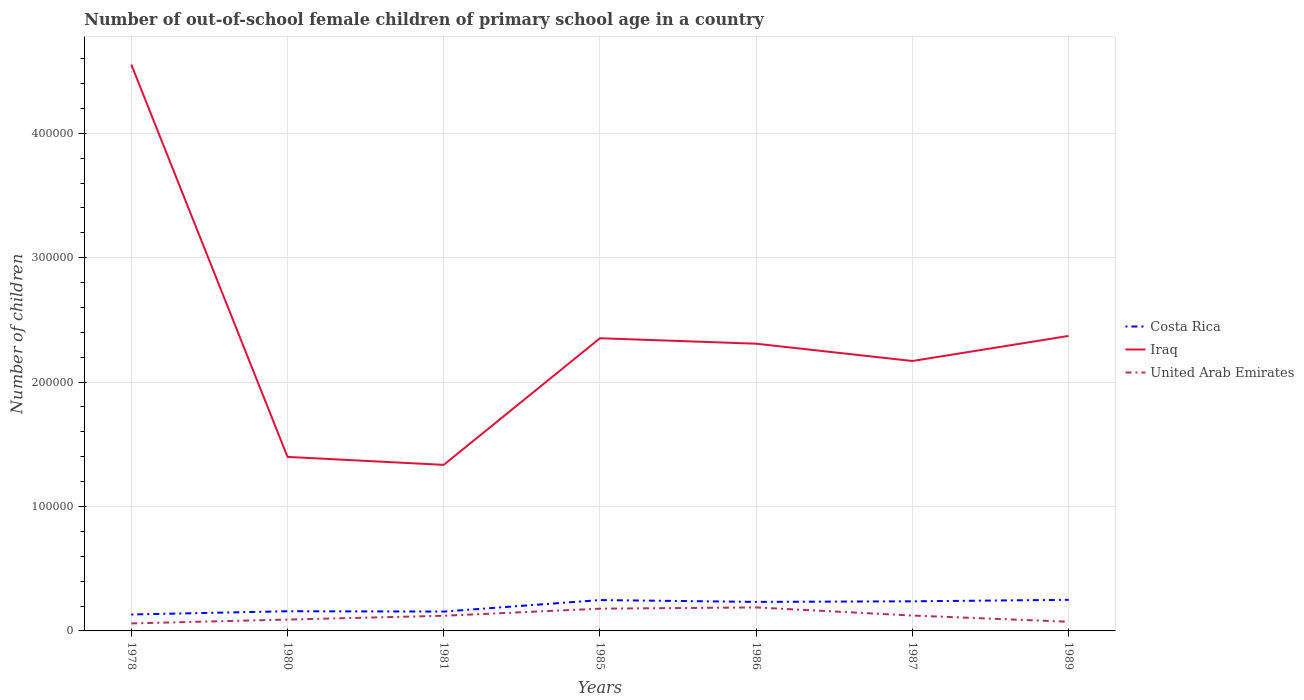How many different coloured lines are there?
Offer a very short reply. 3. Does the line corresponding to Costa Rica intersect with the line corresponding to Iraq?
Your response must be concise. No. Across all years, what is the maximum number of out-of-school female children in Costa Rica?
Your answer should be compact. 1.32e+04. In which year was the number of out-of-school female children in Iraq maximum?
Your answer should be very brief. 1981. What is the total number of out-of-school female children in United Arab Emirates in the graph?
Ensure brevity in your answer.  4973. What is the difference between the highest and the second highest number of out-of-school female children in Iraq?
Ensure brevity in your answer.  3.22e+05. How many lines are there?
Your response must be concise. 3. How many years are there in the graph?
Keep it short and to the point. 7. What is the difference between two consecutive major ticks on the Y-axis?
Provide a succinct answer. 1.00e+05. Are the values on the major ticks of Y-axis written in scientific E-notation?
Ensure brevity in your answer.  No. Does the graph contain any zero values?
Your answer should be very brief. No. Does the graph contain grids?
Offer a very short reply. Yes. Where does the legend appear in the graph?
Make the answer very short. Center right. How many legend labels are there?
Give a very brief answer. 3. How are the legend labels stacked?
Provide a succinct answer. Vertical. What is the title of the graph?
Make the answer very short. Number of out-of-school female children of primary school age in a country. What is the label or title of the Y-axis?
Provide a short and direct response. Number of children. What is the Number of children of Costa Rica in 1978?
Keep it short and to the point. 1.32e+04. What is the Number of children in Iraq in 1978?
Your answer should be very brief. 4.55e+05. What is the Number of children of United Arab Emirates in 1978?
Give a very brief answer. 6031. What is the Number of children in Costa Rica in 1980?
Make the answer very short. 1.58e+04. What is the Number of children of Iraq in 1980?
Keep it short and to the point. 1.40e+05. What is the Number of children of United Arab Emirates in 1980?
Ensure brevity in your answer.  9125. What is the Number of children in Costa Rica in 1981?
Your answer should be very brief. 1.56e+04. What is the Number of children of Iraq in 1981?
Ensure brevity in your answer.  1.33e+05. What is the Number of children of United Arab Emirates in 1981?
Keep it short and to the point. 1.22e+04. What is the Number of children of Costa Rica in 1985?
Offer a terse response. 2.48e+04. What is the Number of children of Iraq in 1985?
Offer a very short reply. 2.35e+05. What is the Number of children in United Arab Emirates in 1985?
Give a very brief answer. 1.79e+04. What is the Number of children of Costa Rica in 1986?
Your answer should be very brief. 2.33e+04. What is the Number of children in Iraq in 1986?
Your answer should be compact. 2.31e+05. What is the Number of children of United Arab Emirates in 1986?
Provide a short and direct response. 1.89e+04. What is the Number of children in Costa Rica in 1987?
Keep it short and to the point. 2.38e+04. What is the Number of children of Iraq in 1987?
Ensure brevity in your answer.  2.17e+05. What is the Number of children of United Arab Emirates in 1987?
Give a very brief answer. 1.24e+04. What is the Number of children of Costa Rica in 1989?
Provide a short and direct response. 2.50e+04. What is the Number of children in Iraq in 1989?
Provide a succinct answer. 2.37e+05. What is the Number of children of United Arab Emirates in 1989?
Ensure brevity in your answer.  7385. Across all years, what is the maximum Number of children of Costa Rica?
Make the answer very short. 2.50e+04. Across all years, what is the maximum Number of children of Iraq?
Give a very brief answer. 4.55e+05. Across all years, what is the maximum Number of children of United Arab Emirates?
Offer a very short reply. 1.89e+04. Across all years, what is the minimum Number of children of Costa Rica?
Offer a very short reply. 1.32e+04. Across all years, what is the minimum Number of children of Iraq?
Keep it short and to the point. 1.33e+05. Across all years, what is the minimum Number of children of United Arab Emirates?
Make the answer very short. 6031. What is the total Number of children of Costa Rica in the graph?
Your answer should be very brief. 1.42e+05. What is the total Number of children of Iraq in the graph?
Provide a succinct answer. 1.65e+06. What is the total Number of children in United Arab Emirates in the graph?
Your answer should be compact. 8.38e+04. What is the difference between the Number of children of Costa Rica in 1978 and that in 1980?
Your answer should be very brief. -2627. What is the difference between the Number of children in Iraq in 1978 and that in 1980?
Provide a succinct answer. 3.15e+05. What is the difference between the Number of children of United Arab Emirates in 1978 and that in 1980?
Offer a terse response. -3094. What is the difference between the Number of children in Costa Rica in 1978 and that in 1981?
Your response must be concise. -2364. What is the difference between the Number of children of Iraq in 1978 and that in 1981?
Keep it short and to the point. 3.22e+05. What is the difference between the Number of children in United Arab Emirates in 1978 and that in 1981?
Your answer should be very brief. -6150. What is the difference between the Number of children of Costa Rica in 1978 and that in 1985?
Provide a succinct answer. -1.16e+04. What is the difference between the Number of children of Iraq in 1978 and that in 1985?
Your answer should be very brief. 2.20e+05. What is the difference between the Number of children in United Arab Emirates in 1978 and that in 1985?
Offer a very short reply. -1.19e+04. What is the difference between the Number of children of Costa Rica in 1978 and that in 1986?
Provide a succinct answer. -1.01e+04. What is the difference between the Number of children of Iraq in 1978 and that in 1986?
Make the answer very short. 2.24e+05. What is the difference between the Number of children of United Arab Emirates in 1978 and that in 1986?
Provide a succinct answer. -1.29e+04. What is the difference between the Number of children in Costa Rica in 1978 and that in 1987?
Provide a succinct answer. -1.06e+04. What is the difference between the Number of children in Iraq in 1978 and that in 1987?
Give a very brief answer. 2.38e+05. What is the difference between the Number of children of United Arab Emirates in 1978 and that in 1987?
Your response must be concise. -6327. What is the difference between the Number of children of Costa Rica in 1978 and that in 1989?
Offer a very short reply. -1.18e+04. What is the difference between the Number of children in Iraq in 1978 and that in 1989?
Your response must be concise. 2.18e+05. What is the difference between the Number of children of United Arab Emirates in 1978 and that in 1989?
Offer a very short reply. -1354. What is the difference between the Number of children of Costa Rica in 1980 and that in 1981?
Provide a succinct answer. 263. What is the difference between the Number of children in Iraq in 1980 and that in 1981?
Keep it short and to the point. 6397. What is the difference between the Number of children of United Arab Emirates in 1980 and that in 1981?
Offer a very short reply. -3056. What is the difference between the Number of children in Costa Rica in 1980 and that in 1985?
Provide a succinct answer. -8973. What is the difference between the Number of children in Iraq in 1980 and that in 1985?
Offer a very short reply. -9.54e+04. What is the difference between the Number of children of United Arab Emirates in 1980 and that in 1985?
Your answer should be very brief. -8760. What is the difference between the Number of children of Costa Rica in 1980 and that in 1986?
Provide a succinct answer. -7512. What is the difference between the Number of children of Iraq in 1980 and that in 1986?
Offer a terse response. -9.10e+04. What is the difference between the Number of children in United Arab Emirates in 1980 and that in 1986?
Ensure brevity in your answer.  -9758. What is the difference between the Number of children in Costa Rica in 1980 and that in 1987?
Provide a short and direct response. -7978. What is the difference between the Number of children in Iraq in 1980 and that in 1987?
Give a very brief answer. -7.71e+04. What is the difference between the Number of children in United Arab Emirates in 1980 and that in 1987?
Provide a short and direct response. -3233. What is the difference between the Number of children of Costa Rica in 1980 and that in 1989?
Provide a short and direct response. -9174. What is the difference between the Number of children in Iraq in 1980 and that in 1989?
Keep it short and to the point. -9.72e+04. What is the difference between the Number of children of United Arab Emirates in 1980 and that in 1989?
Your response must be concise. 1740. What is the difference between the Number of children of Costa Rica in 1981 and that in 1985?
Your answer should be very brief. -9236. What is the difference between the Number of children in Iraq in 1981 and that in 1985?
Ensure brevity in your answer.  -1.02e+05. What is the difference between the Number of children of United Arab Emirates in 1981 and that in 1985?
Your response must be concise. -5704. What is the difference between the Number of children of Costa Rica in 1981 and that in 1986?
Your answer should be very brief. -7775. What is the difference between the Number of children in Iraq in 1981 and that in 1986?
Offer a very short reply. -9.74e+04. What is the difference between the Number of children in United Arab Emirates in 1981 and that in 1986?
Offer a terse response. -6702. What is the difference between the Number of children of Costa Rica in 1981 and that in 1987?
Offer a very short reply. -8241. What is the difference between the Number of children of Iraq in 1981 and that in 1987?
Keep it short and to the point. -8.35e+04. What is the difference between the Number of children in United Arab Emirates in 1981 and that in 1987?
Your response must be concise. -177. What is the difference between the Number of children of Costa Rica in 1981 and that in 1989?
Offer a terse response. -9437. What is the difference between the Number of children of Iraq in 1981 and that in 1989?
Keep it short and to the point. -1.04e+05. What is the difference between the Number of children of United Arab Emirates in 1981 and that in 1989?
Your answer should be compact. 4796. What is the difference between the Number of children of Costa Rica in 1985 and that in 1986?
Give a very brief answer. 1461. What is the difference between the Number of children of Iraq in 1985 and that in 1986?
Ensure brevity in your answer.  4392. What is the difference between the Number of children in United Arab Emirates in 1985 and that in 1986?
Your answer should be very brief. -998. What is the difference between the Number of children of Costa Rica in 1985 and that in 1987?
Your answer should be very brief. 995. What is the difference between the Number of children of Iraq in 1985 and that in 1987?
Ensure brevity in your answer.  1.83e+04. What is the difference between the Number of children in United Arab Emirates in 1985 and that in 1987?
Make the answer very short. 5527. What is the difference between the Number of children in Costa Rica in 1985 and that in 1989?
Make the answer very short. -201. What is the difference between the Number of children of Iraq in 1985 and that in 1989?
Make the answer very short. -1859. What is the difference between the Number of children of United Arab Emirates in 1985 and that in 1989?
Ensure brevity in your answer.  1.05e+04. What is the difference between the Number of children in Costa Rica in 1986 and that in 1987?
Offer a very short reply. -466. What is the difference between the Number of children in Iraq in 1986 and that in 1987?
Your response must be concise. 1.39e+04. What is the difference between the Number of children of United Arab Emirates in 1986 and that in 1987?
Make the answer very short. 6525. What is the difference between the Number of children in Costa Rica in 1986 and that in 1989?
Your response must be concise. -1662. What is the difference between the Number of children in Iraq in 1986 and that in 1989?
Give a very brief answer. -6251. What is the difference between the Number of children in United Arab Emirates in 1986 and that in 1989?
Give a very brief answer. 1.15e+04. What is the difference between the Number of children in Costa Rica in 1987 and that in 1989?
Make the answer very short. -1196. What is the difference between the Number of children in Iraq in 1987 and that in 1989?
Give a very brief answer. -2.02e+04. What is the difference between the Number of children in United Arab Emirates in 1987 and that in 1989?
Keep it short and to the point. 4973. What is the difference between the Number of children in Costa Rica in 1978 and the Number of children in Iraq in 1980?
Offer a very short reply. -1.27e+05. What is the difference between the Number of children in Costa Rica in 1978 and the Number of children in United Arab Emirates in 1980?
Give a very brief answer. 4072. What is the difference between the Number of children of Iraq in 1978 and the Number of children of United Arab Emirates in 1980?
Keep it short and to the point. 4.46e+05. What is the difference between the Number of children in Costa Rica in 1978 and the Number of children in Iraq in 1981?
Your response must be concise. -1.20e+05. What is the difference between the Number of children in Costa Rica in 1978 and the Number of children in United Arab Emirates in 1981?
Provide a short and direct response. 1016. What is the difference between the Number of children in Iraq in 1978 and the Number of children in United Arab Emirates in 1981?
Give a very brief answer. 4.43e+05. What is the difference between the Number of children of Costa Rica in 1978 and the Number of children of Iraq in 1985?
Keep it short and to the point. -2.22e+05. What is the difference between the Number of children of Costa Rica in 1978 and the Number of children of United Arab Emirates in 1985?
Your response must be concise. -4688. What is the difference between the Number of children in Iraq in 1978 and the Number of children in United Arab Emirates in 1985?
Offer a terse response. 4.37e+05. What is the difference between the Number of children in Costa Rica in 1978 and the Number of children in Iraq in 1986?
Offer a terse response. -2.18e+05. What is the difference between the Number of children of Costa Rica in 1978 and the Number of children of United Arab Emirates in 1986?
Your answer should be compact. -5686. What is the difference between the Number of children in Iraq in 1978 and the Number of children in United Arab Emirates in 1986?
Give a very brief answer. 4.36e+05. What is the difference between the Number of children in Costa Rica in 1978 and the Number of children in Iraq in 1987?
Offer a very short reply. -2.04e+05. What is the difference between the Number of children of Costa Rica in 1978 and the Number of children of United Arab Emirates in 1987?
Offer a very short reply. 839. What is the difference between the Number of children of Iraq in 1978 and the Number of children of United Arab Emirates in 1987?
Provide a short and direct response. 4.43e+05. What is the difference between the Number of children in Costa Rica in 1978 and the Number of children in Iraq in 1989?
Provide a succinct answer. -2.24e+05. What is the difference between the Number of children in Costa Rica in 1978 and the Number of children in United Arab Emirates in 1989?
Provide a succinct answer. 5812. What is the difference between the Number of children of Iraq in 1978 and the Number of children of United Arab Emirates in 1989?
Provide a succinct answer. 4.48e+05. What is the difference between the Number of children in Costa Rica in 1980 and the Number of children in Iraq in 1981?
Your answer should be compact. -1.18e+05. What is the difference between the Number of children in Costa Rica in 1980 and the Number of children in United Arab Emirates in 1981?
Keep it short and to the point. 3643. What is the difference between the Number of children of Iraq in 1980 and the Number of children of United Arab Emirates in 1981?
Give a very brief answer. 1.28e+05. What is the difference between the Number of children in Costa Rica in 1980 and the Number of children in Iraq in 1985?
Your answer should be compact. -2.19e+05. What is the difference between the Number of children in Costa Rica in 1980 and the Number of children in United Arab Emirates in 1985?
Keep it short and to the point. -2061. What is the difference between the Number of children in Iraq in 1980 and the Number of children in United Arab Emirates in 1985?
Your answer should be compact. 1.22e+05. What is the difference between the Number of children of Costa Rica in 1980 and the Number of children of Iraq in 1986?
Your answer should be very brief. -2.15e+05. What is the difference between the Number of children in Costa Rica in 1980 and the Number of children in United Arab Emirates in 1986?
Provide a short and direct response. -3059. What is the difference between the Number of children of Iraq in 1980 and the Number of children of United Arab Emirates in 1986?
Offer a very short reply. 1.21e+05. What is the difference between the Number of children of Costa Rica in 1980 and the Number of children of Iraq in 1987?
Provide a short and direct response. -2.01e+05. What is the difference between the Number of children in Costa Rica in 1980 and the Number of children in United Arab Emirates in 1987?
Your response must be concise. 3466. What is the difference between the Number of children of Iraq in 1980 and the Number of children of United Arab Emirates in 1987?
Provide a succinct answer. 1.28e+05. What is the difference between the Number of children in Costa Rica in 1980 and the Number of children in Iraq in 1989?
Make the answer very short. -2.21e+05. What is the difference between the Number of children of Costa Rica in 1980 and the Number of children of United Arab Emirates in 1989?
Your answer should be compact. 8439. What is the difference between the Number of children of Iraq in 1980 and the Number of children of United Arab Emirates in 1989?
Provide a succinct answer. 1.32e+05. What is the difference between the Number of children in Costa Rica in 1981 and the Number of children in Iraq in 1985?
Your response must be concise. -2.20e+05. What is the difference between the Number of children of Costa Rica in 1981 and the Number of children of United Arab Emirates in 1985?
Your answer should be very brief. -2324. What is the difference between the Number of children of Iraq in 1981 and the Number of children of United Arab Emirates in 1985?
Keep it short and to the point. 1.16e+05. What is the difference between the Number of children in Costa Rica in 1981 and the Number of children in Iraq in 1986?
Ensure brevity in your answer.  -2.15e+05. What is the difference between the Number of children in Costa Rica in 1981 and the Number of children in United Arab Emirates in 1986?
Offer a very short reply. -3322. What is the difference between the Number of children in Iraq in 1981 and the Number of children in United Arab Emirates in 1986?
Your answer should be compact. 1.15e+05. What is the difference between the Number of children in Costa Rica in 1981 and the Number of children in Iraq in 1987?
Ensure brevity in your answer.  -2.01e+05. What is the difference between the Number of children in Costa Rica in 1981 and the Number of children in United Arab Emirates in 1987?
Give a very brief answer. 3203. What is the difference between the Number of children in Iraq in 1981 and the Number of children in United Arab Emirates in 1987?
Ensure brevity in your answer.  1.21e+05. What is the difference between the Number of children of Costa Rica in 1981 and the Number of children of Iraq in 1989?
Your answer should be very brief. -2.22e+05. What is the difference between the Number of children of Costa Rica in 1981 and the Number of children of United Arab Emirates in 1989?
Keep it short and to the point. 8176. What is the difference between the Number of children of Iraq in 1981 and the Number of children of United Arab Emirates in 1989?
Give a very brief answer. 1.26e+05. What is the difference between the Number of children of Costa Rica in 1985 and the Number of children of Iraq in 1986?
Give a very brief answer. -2.06e+05. What is the difference between the Number of children of Costa Rica in 1985 and the Number of children of United Arab Emirates in 1986?
Your answer should be very brief. 5914. What is the difference between the Number of children of Iraq in 1985 and the Number of children of United Arab Emirates in 1986?
Your answer should be compact. 2.16e+05. What is the difference between the Number of children of Costa Rica in 1985 and the Number of children of Iraq in 1987?
Provide a short and direct response. -1.92e+05. What is the difference between the Number of children of Costa Rica in 1985 and the Number of children of United Arab Emirates in 1987?
Give a very brief answer. 1.24e+04. What is the difference between the Number of children in Iraq in 1985 and the Number of children in United Arab Emirates in 1987?
Offer a very short reply. 2.23e+05. What is the difference between the Number of children of Costa Rica in 1985 and the Number of children of Iraq in 1989?
Your answer should be very brief. -2.12e+05. What is the difference between the Number of children of Costa Rica in 1985 and the Number of children of United Arab Emirates in 1989?
Provide a short and direct response. 1.74e+04. What is the difference between the Number of children in Iraq in 1985 and the Number of children in United Arab Emirates in 1989?
Provide a succinct answer. 2.28e+05. What is the difference between the Number of children in Costa Rica in 1986 and the Number of children in Iraq in 1987?
Ensure brevity in your answer.  -1.94e+05. What is the difference between the Number of children of Costa Rica in 1986 and the Number of children of United Arab Emirates in 1987?
Offer a very short reply. 1.10e+04. What is the difference between the Number of children of Iraq in 1986 and the Number of children of United Arab Emirates in 1987?
Provide a succinct answer. 2.19e+05. What is the difference between the Number of children in Costa Rica in 1986 and the Number of children in Iraq in 1989?
Your response must be concise. -2.14e+05. What is the difference between the Number of children of Costa Rica in 1986 and the Number of children of United Arab Emirates in 1989?
Your response must be concise. 1.60e+04. What is the difference between the Number of children of Iraq in 1986 and the Number of children of United Arab Emirates in 1989?
Ensure brevity in your answer.  2.23e+05. What is the difference between the Number of children of Costa Rica in 1987 and the Number of children of Iraq in 1989?
Make the answer very short. -2.13e+05. What is the difference between the Number of children of Costa Rica in 1987 and the Number of children of United Arab Emirates in 1989?
Offer a very short reply. 1.64e+04. What is the difference between the Number of children in Iraq in 1987 and the Number of children in United Arab Emirates in 1989?
Give a very brief answer. 2.10e+05. What is the average Number of children of Costa Rica per year?
Your answer should be very brief. 2.02e+04. What is the average Number of children of Iraq per year?
Make the answer very short. 2.36e+05. What is the average Number of children in United Arab Emirates per year?
Your response must be concise. 1.20e+04. In the year 1978, what is the difference between the Number of children of Costa Rica and Number of children of Iraq?
Make the answer very short. -4.42e+05. In the year 1978, what is the difference between the Number of children of Costa Rica and Number of children of United Arab Emirates?
Provide a succinct answer. 7166. In the year 1978, what is the difference between the Number of children in Iraq and Number of children in United Arab Emirates?
Keep it short and to the point. 4.49e+05. In the year 1980, what is the difference between the Number of children in Costa Rica and Number of children in Iraq?
Provide a succinct answer. -1.24e+05. In the year 1980, what is the difference between the Number of children of Costa Rica and Number of children of United Arab Emirates?
Ensure brevity in your answer.  6699. In the year 1980, what is the difference between the Number of children in Iraq and Number of children in United Arab Emirates?
Offer a very short reply. 1.31e+05. In the year 1981, what is the difference between the Number of children of Costa Rica and Number of children of Iraq?
Make the answer very short. -1.18e+05. In the year 1981, what is the difference between the Number of children of Costa Rica and Number of children of United Arab Emirates?
Provide a succinct answer. 3380. In the year 1981, what is the difference between the Number of children of Iraq and Number of children of United Arab Emirates?
Provide a short and direct response. 1.21e+05. In the year 1985, what is the difference between the Number of children of Costa Rica and Number of children of Iraq?
Your answer should be compact. -2.10e+05. In the year 1985, what is the difference between the Number of children in Costa Rica and Number of children in United Arab Emirates?
Give a very brief answer. 6912. In the year 1985, what is the difference between the Number of children of Iraq and Number of children of United Arab Emirates?
Your response must be concise. 2.17e+05. In the year 1986, what is the difference between the Number of children of Costa Rica and Number of children of Iraq?
Keep it short and to the point. -2.08e+05. In the year 1986, what is the difference between the Number of children in Costa Rica and Number of children in United Arab Emirates?
Your response must be concise. 4453. In the year 1986, what is the difference between the Number of children in Iraq and Number of children in United Arab Emirates?
Provide a succinct answer. 2.12e+05. In the year 1987, what is the difference between the Number of children in Costa Rica and Number of children in Iraq?
Provide a succinct answer. -1.93e+05. In the year 1987, what is the difference between the Number of children in Costa Rica and Number of children in United Arab Emirates?
Give a very brief answer. 1.14e+04. In the year 1987, what is the difference between the Number of children in Iraq and Number of children in United Arab Emirates?
Your answer should be compact. 2.05e+05. In the year 1989, what is the difference between the Number of children in Costa Rica and Number of children in Iraq?
Provide a succinct answer. -2.12e+05. In the year 1989, what is the difference between the Number of children in Costa Rica and Number of children in United Arab Emirates?
Keep it short and to the point. 1.76e+04. In the year 1989, what is the difference between the Number of children of Iraq and Number of children of United Arab Emirates?
Provide a succinct answer. 2.30e+05. What is the ratio of the Number of children of Costa Rica in 1978 to that in 1980?
Provide a succinct answer. 0.83. What is the ratio of the Number of children of Iraq in 1978 to that in 1980?
Offer a very short reply. 3.25. What is the ratio of the Number of children of United Arab Emirates in 1978 to that in 1980?
Give a very brief answer. 0.66. What is the ratio of the Number of children in Costa Rica in 1978 to that in 1981?
Your response must be concise. 0.85. What is the ratio of the Number of children in Iraq in 1978 to that in 1981?
Ensure brevity in your answer.  3.41. What is the ratio of the Number of children of United Arab Emirates in 1978 to that in 1981?
Your answer should be very brief. 0.5. What is the ratio of the Number of children in Costa Rica in 1978 to that in 1985?
Keep it short and to the point. 0.53. What is the ratio of the Number of children of Iraq in 1978 to that in 1985?
Keep it short and to the point. 1.94. What is the ratio of the Number of children of United Arab Emirates in 1978 to that in 1985?
Offer a terse response. 0.34. What is the ratio of the Number of children in Costa Rica in 1978 to that in 1986?
Ensure brevity in your answer.  0.57. What is the ratio of the Number of children of Iraq in 1978 to that in 1986?
Offer a terse response. 1.97. What is the ratio of the Number of children in United Arab Emirates in 1978 to that in 1986?
Your answer should be very brief. 0.32. What is the ratio of the Number of children in Costa Rica in 1978 to that in 1987?
Provide a succinct answer. 0.55. What is the ratio of the Number of children in Iraq in 1978 to that in 1987?
Ensure brevity in your answer.  2.1. What is the ratio of the Number of children in United Arab Emirates in 1978 to that in 1987?
Give a very brief answer. 0.49. What is the ratio of the Number of children in Costa Rica in 1978 to that in 1989?
Give a very brief answer. 0.53. What is the ratio of the Number of children of Iraq in 1978 to that in 1989?
Give a very brief answer. 1.92. What is the ratio of the Number of children in United Arab Emirates in 1978 to that in 1989?
Offer a terse response. 0.82. What is the ratio of the Number of children of Costa Rica in 1980 to that in 1981?
Ensure brevity in your answer.  1.02. What is the ratio of the Number of children in Iraq in 1980 to that in 1981?
Your answer should be very brief. 1.05. What is the ratio of the Number of children of United Arab Emirates in 1980 to that in 1981?
Make the answer very short. 0.75. What is the ratio of the Number of children of Costa Rica in 1980 to that in 1985?
Your answer should be compact. 0.64. What is the ratio of the Number of children of Iraq in 1980 to that in 1985?
Make the answer very short. 0.59. What is the ratio of the Number of children of United Arab Emirates in 1980 to that in 1985?
Offer a terse response. 0.51. What is the ratio of the Number of children in Costa Rica in 1980 to that in 1986?
Your answer should be compact. 0.68. What is the ratio of the Number of children in Iraq in 1980 to that in 1986?
Make the answer very short. 0.61. What is the ratio of the Number of children in United Arab Emirates in 1980 to that in 1986?
Your answer should be compact. 0.48. What is the ratio of the Number of children in Costa Rica in 1980 to that in 1987?
Provide a short and direct response. 0.66. What is the ratio of the Number of children in Iraq in 1980 to that in 1987?
Keep it short and to the point. 0.64. What is the ratio of the Number of children in United Arab Emirates in 1980 to that in 1987?
Offer a very short reply. 0.74. What is the ratio of the Number of children of Costa Rica in 1980 to that in 1989?
Your response must be concise. 0.63. What is the ratio of the Number of children of Iraq in 1980 to that in 1989?
Make the answer very short. 0.59. What is the ratio of the Number of children of United Arab Emirates in 1980 to that in 1989?
Your response must be concise. 1.24. What is the ratio of the Number of children in Costa Rica in 1981 to that in 1985?
Offer a terse response. 0.63. What is the ratio of the Number of children in Iraq in 1981 to that in 1985?
Provide a short and direct response. 0.57. What is the ratio of the Number of children of United Arab Emirates in 1981 to that in 1985?
Your response must be concise. 0.68. What is the ratio of the Number of children in Costa Rica in 1981 to that in 1986?
Ensure brevity in your answer.  0.67. What is the ratio of the Number of children of Iraq in 1981 to that in 1986?
Your response must be concise. 0.58. What is the ratio of the Number of children in United Arab Emirates in 1981 to that in 1986?
Provide a succinct answer. 0.65. What is the ratio of the Number of children of Costa Rica in 1981 to that in 1987?
Offer a terse response. 0.65. What is the ratio of the Number of children of Iraq in 1981 to that in 1987?
Provide a short and direct response. 0.62. What is the ratio of the Number of children in United Arab Emirates in 1981 to that in 1987?
Your answer should be very brief. 0.99. What is the ratio of the Number of children in Costa Rica in 1981 to that in 1989?
Ensure brevity in your answer.  0.62. What is the ratio of the Number of children of Iraq in 1981 to that in 1989?
Make the answer very short. 0.56. What is the ratio of the Number of children in United Arab Emirates in 1981 to that in 1989?
Your response must be concise. 1.65. What is the ratio of the Number of children of Costa Rica in 1985 to that in 1986?
Provide a short and direct response. 1.06. What is the ratio of the Number of children in United Arab Emirates in 1985 to that in 1986?
Your answer should be very brief. 0.95. What is the ratio of the Number of children in Costa Rica in 1985 to that in 1987?
Provide a succinct answer. 1.04. What is the ratio of the Number of children in Iraq in 1985 to that in 1987?
Your answer should be very brief. 1.08. What is the ratio of the Number of children of United Arab Emirates in 1985 to that in 1987?
Make the answer very short. 1.45. What is the ratio of the Number of children of United Arab Emirates in 1985 to that in 1989?
Keep it short and to the point. 2.42. What is the ratio of the Number of children in Costa Rica in 1986 to that in 1987?
Make the answer very short. 0.98. What is the ratio of the Number of children in Iraq in 1986 to that in 1987?
Give a very brief answer. 1.06. What is the ratio of the Number of children of United Arab Emirates in 1986 to that in 1987?
Give a very brief answer. 1.53. What is the ratio of the Number of children in Costa Rica in 1986 to that in 1989?
Provide a short and direct response. 0.93. What is the ratio of the Number of children of Iraq in 1986 to that in 1989?
Offer a very short reply. 0.97. What is the ratio of the Number of children in United Arab Emirates in 1986 to that in 1989?
Your answer should be very brief. 2.56. What is the ratio of the Number of children of Costa Rica in 1987 to that in 1989?
Your answer should be compact. 0.95. What is the ratio of the Number of children in Iraq in 1987 to that in 1989?
Offer a very short reply. 0.92. What is the ratio of the Number of children of United Arab Emirates in 1987 to that in 1989?
Offer a terse response. 1.67. What is the difference between the highest and the second highest Number of children in Costa Rica?
Your answer should be compact. 201. What is the difference between the highest and the second highest Number of children of Iraq?
Make the answer very short. 2.18e+05. What is the difference between the highest and the second highest Number of children of United Arab Emirates?
Keep it short and to the point. 998. What is the difference between the highest and the lowest Number of children of Costa Rica?
Offer a very short reply. 1.18e+04. What is the difference between the highest and the lowest Number of children of Iraq?
Make the answer very short. 3.22e+05. What is the difference between the highest and the lowest Number of children of United Arab Emirates?
Offer a very short reply. 1.29e+04. 